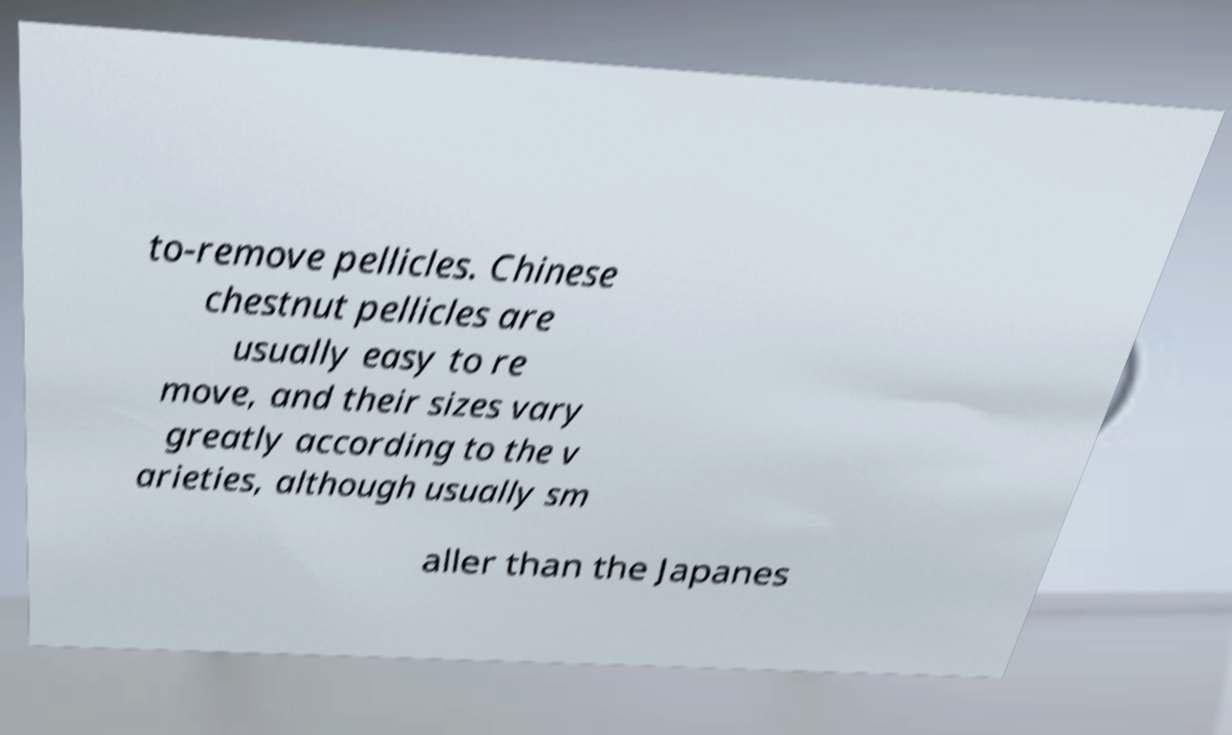Can you read and provide the text displayed in the image?This photo seems to have some interesting text. Can you extract and type it out for me? to-remove pellicles. Chinese chestnut pellicles are usually easy to re move, and their sizes vary greatly according to the v arieties, although usually sm aller than the Japanes 